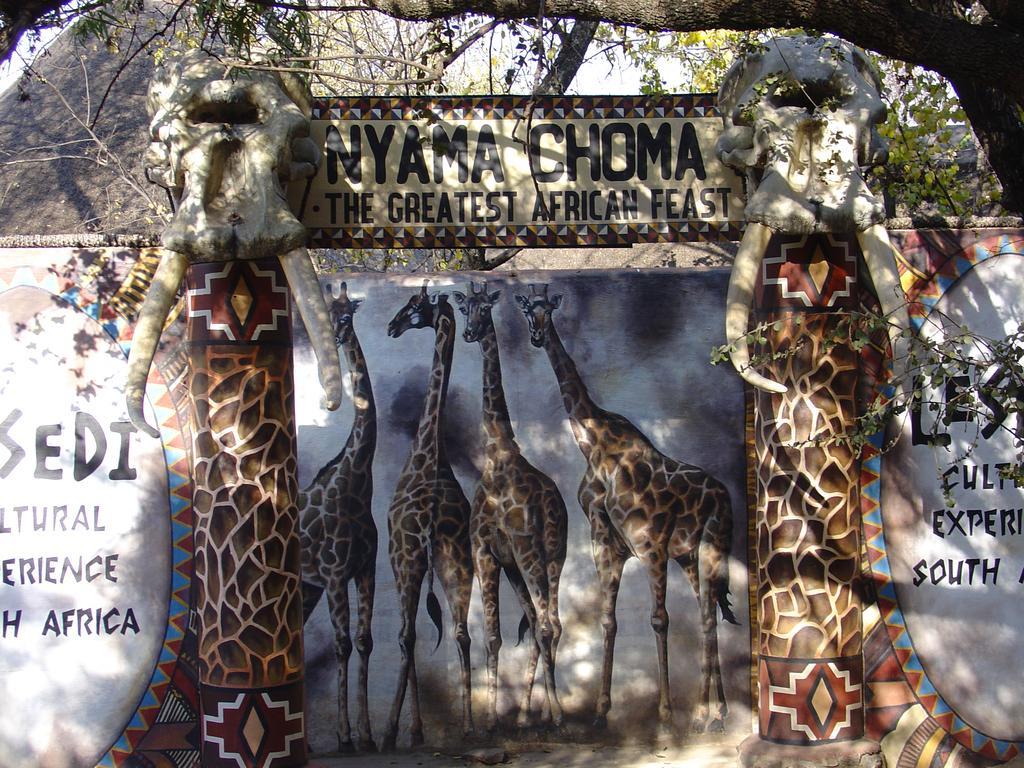How would you summarize this image in a sentence or two? In this picture we can see an arch and on the arch there are sculptures, tusks and a name board. Behind the arch there's a wall with paintings and behind the wall there is a rock, trees and the sky. 